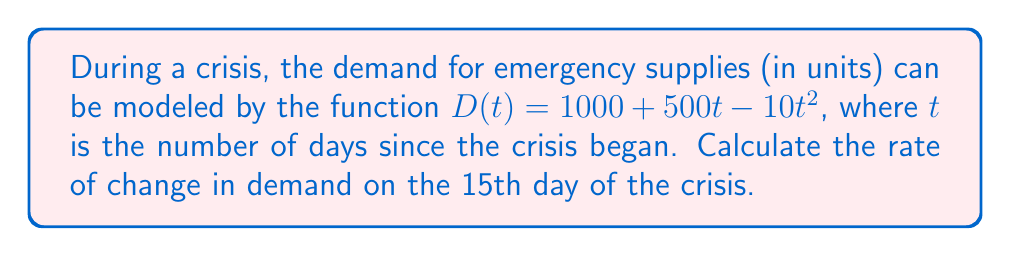Can you answer this question? To solve this problem, we need to follow these steps:

1) The rate of change in demand is given by the derivative of the demand function $D(t)$.

2) Let's find the derivative of $D(t)$:
   $$\frac{d}{dt}D(t) = \frac{d}{dt}(1000 + 500t - 10t^2)$$
   $$D'(t) = 500 - 20t$$

3) The question asks for the rate of change on the 15th day, so we need to evaluate $D'(t)$ at $t = 15$:
   $$D'(15) = 500 - 20(15)$$
   $$D'(15) = 500 - 300 = 200$$

4) Interpret the result: The rate of change is 200 units per day, which means the demand is increasing by 200 units per day on the 15th day of the crisis.

As an experienced entrepreneur in emergency supplies, understanding this rate of change is crucial for inventory management and meeting customer needs during a crisis.
Answer: 200 units/day 